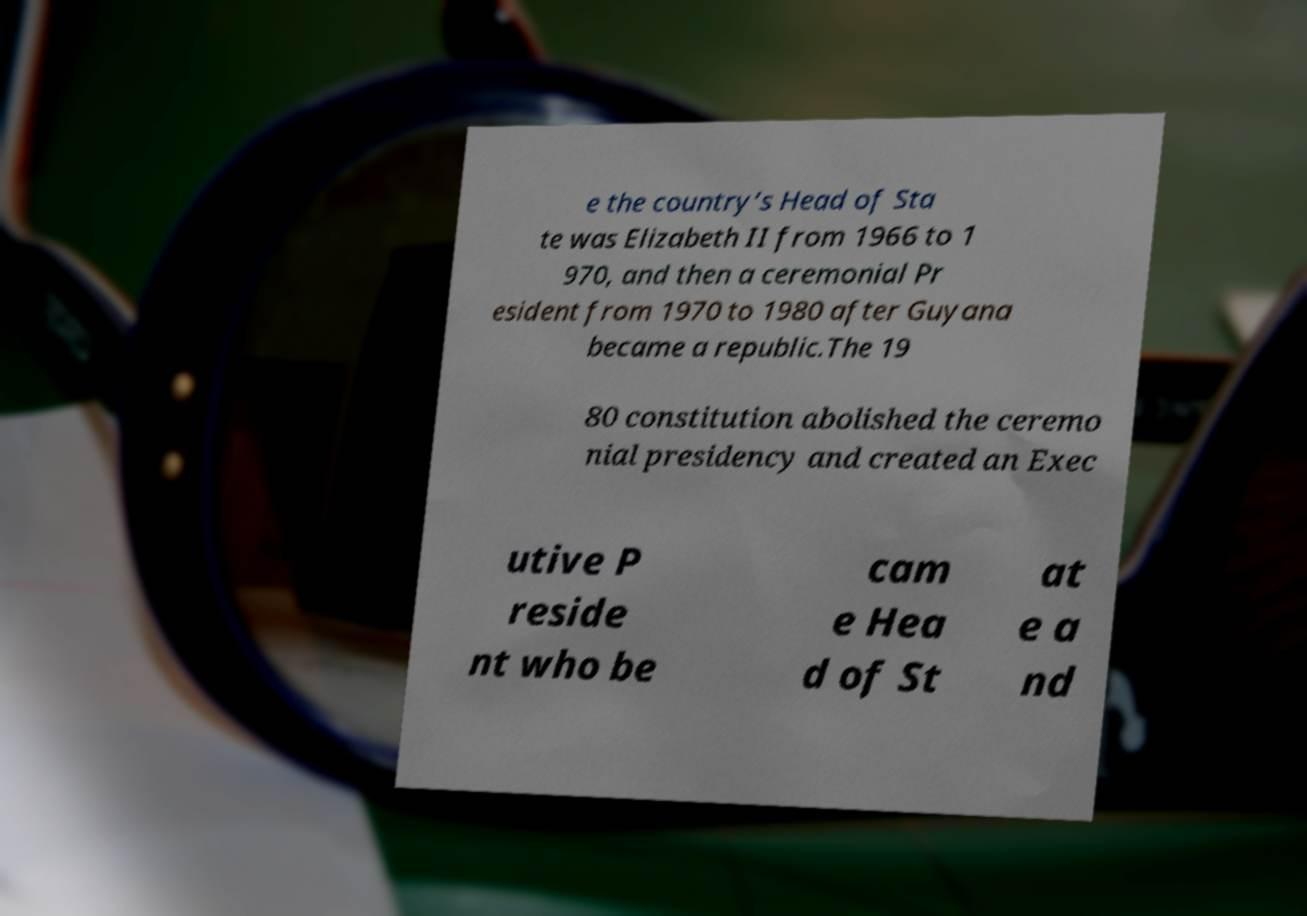Can you accurately transcribe the text from the provided image for me? e the country’s Head of Sta te was Elizabeth II from 1966 to 1 970, and then a ceremonial Pr esident from 1970 to 1980 after Guyana became a republic.The 19 80 constitution abolished the ceremo nial presidency and created an Exec utive P reside nt who be cam e Hea d of St at e a nd 